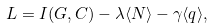Convert formula to latex. <formula><loc_0><loc_0><loc_500><loc_500>L = I ( G , C ) - \lambda \langle N \rangle - \gamma \langle q \rangle ,</formula> 